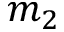<formula> <loc_0><loc_0><loc_500><loc_500>m _ { 2 }</formula> 